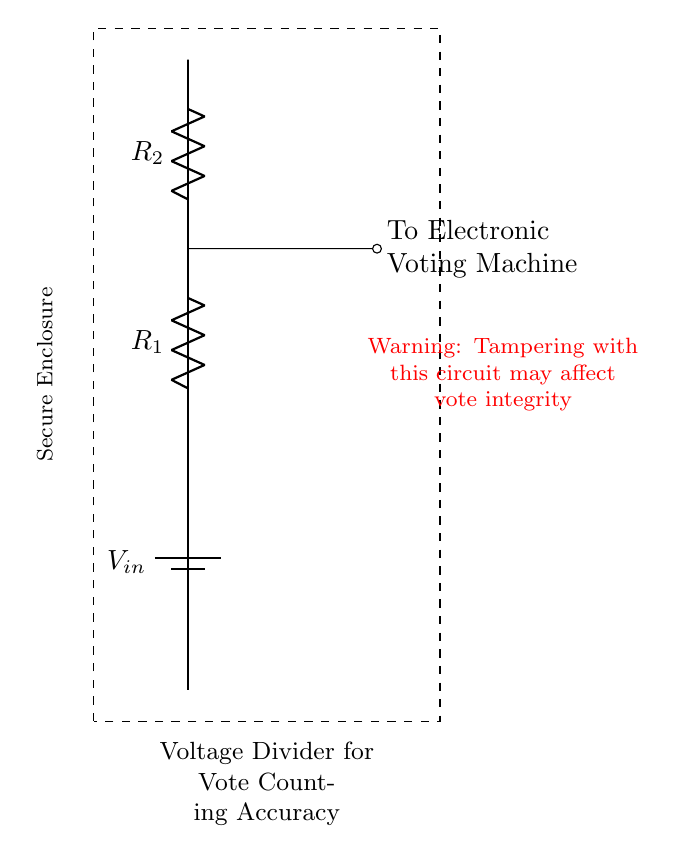What is the input voltage of the circuit? The circuit indicates that the input voltage is labeled as V_in. There is no numerical value provided, so the answer refers to the label in the circuit.
Answer: V_in What are the two resistors in the voltage divider? The circuit diagram shows two resistors, labeled as R_1 and R_2. These resistors are crucial components in the voltage divider configuration.
Answer: R_1, R_2 What is indicated by the dashed rectangle in the circuit? The dashed rectangle signifies a secure enclosure. This note emphasizes the importance of protecting the voltage divider circuit from tampering to maintain vote integrity.
Answer: Secure Enclosure Which component connects to the electronic voting machine? The connection indicated is made from the junction between R_1 and R_2. The line labeled “To Electronic Voting Machine” shows this output connection.
Answer: To Electronic Voting Machine What warning is provided in the circuit? The circuit contains a warning label that states tampering with the circuit may affect vote integrity. This serves as a cautionary note about the importance of the circuit's security.
Answer: Warning: Tampering may affect vote integrity How does this voltage divider help in electronic voting machines? The voltage divider provides a specific voltage output based on the ratio of R_1 to R_2 which is essential for the accurate measurement of voting data within the electronic voting machines.
Answer: Accurate vote counting 